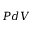<formula> <loc_0><loc_0><loc_500><loc_500>P d V</formula> 